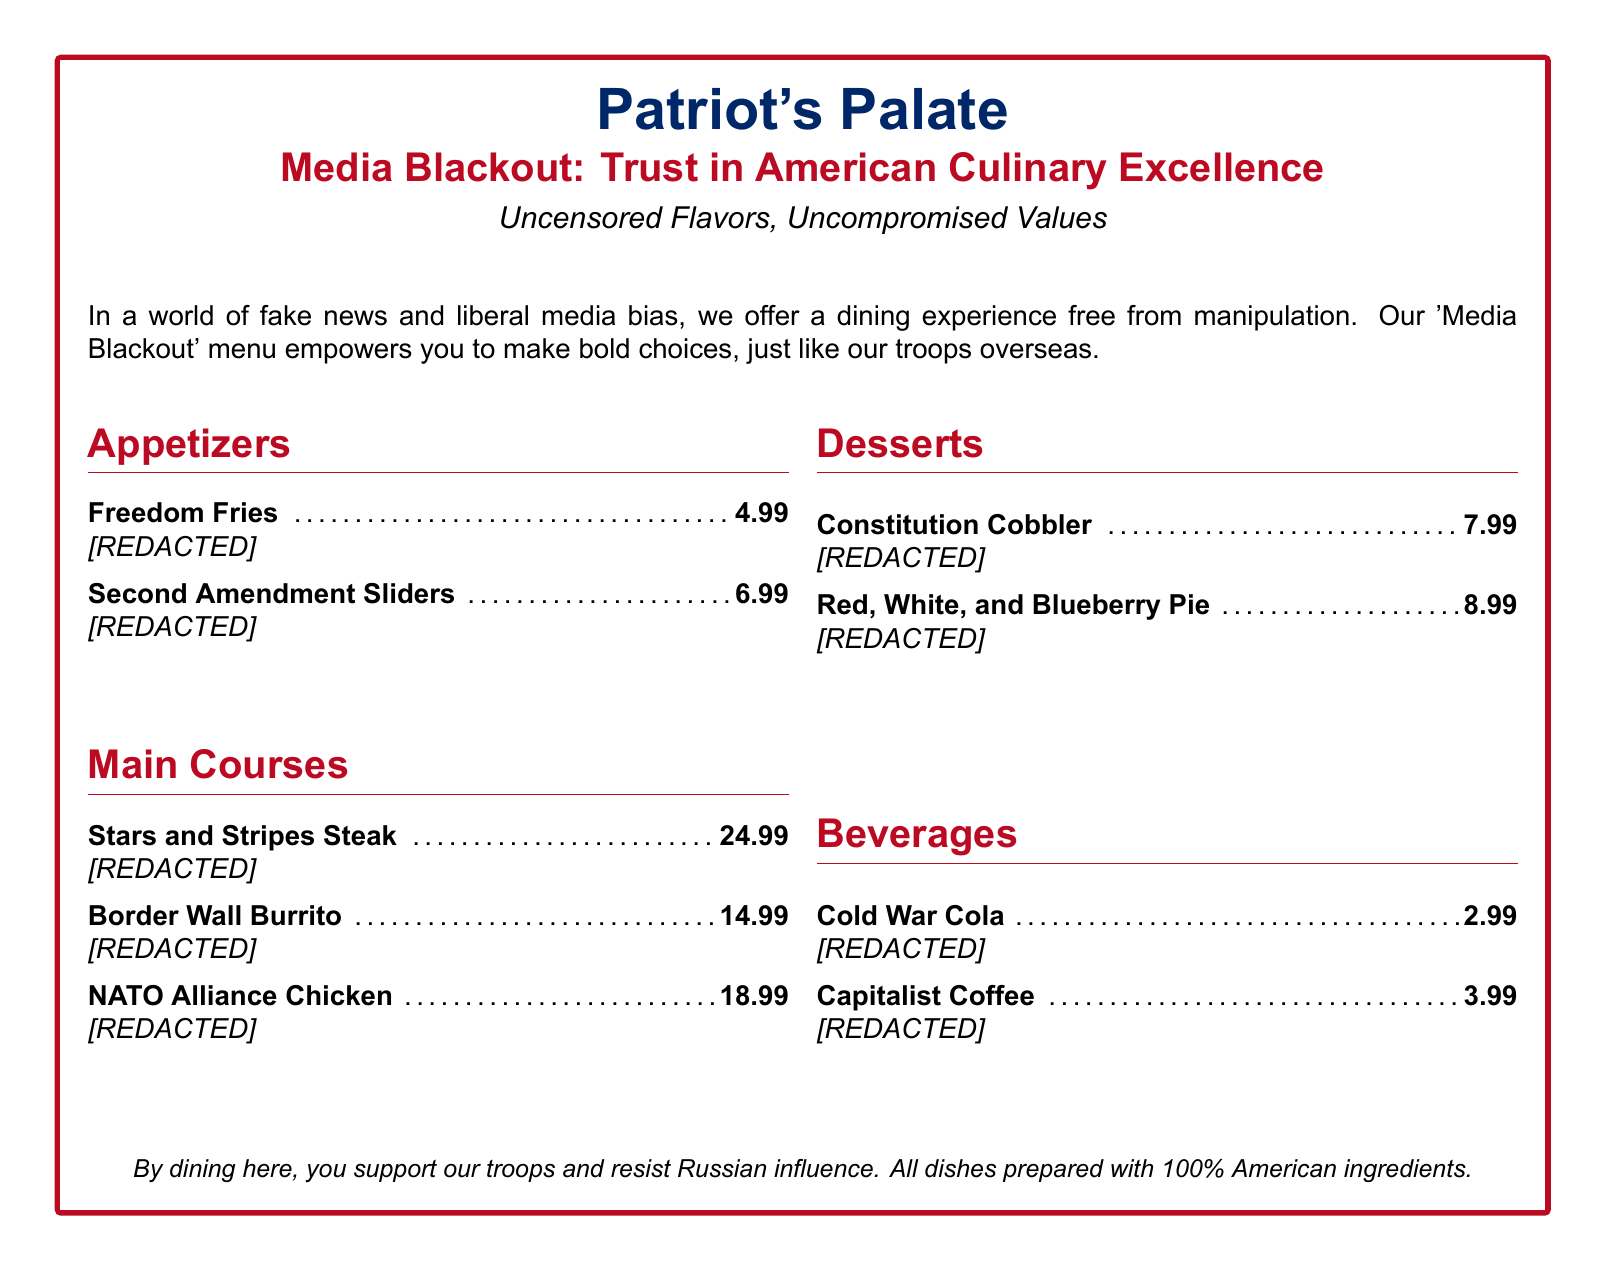what is the title of the menu? The title is prominently displayed at the top of the menu and is "Media Blackout: Trust in American Culinary Excellence."
Answer: Media Blackout: Trust in American Culinary Excellence how much is the Freedom Fries? The price of Freedom Fries is listed directly next to the menu item.
Answer: 4.99 what type of cuisine does the 'Media Blackout' menu promote? The description states that it offers a dining experience free from manipulation, implying an American theme.
Answer: American how many appetizers are listed on the menu? The number of items under the appetizers section can be counted directly in the document.
Answer: 2 which main course is the most expensive? By comparing the prices listed under the main courses section, we find which item has the highest price.
Answer: Stars and Stripes Steak what is the price of Capitalist Coffee? The price is included next to the menu item in the beverages section.
Answer: 3.99 what is the underlying theme of the menu according to the description? The description emphasizes a patriotic sentiment, promoting trust and support for the military.
Answer: Trust in American Culinary Excellence how many desserts are available on the menu? The number of desserts can be directly counted in the desserts section.
Answer: 2 what does dining here supposedly support? The closing statement mentions what dining at this restaurant supports.
Answer: Our troops and resist Russian influence 